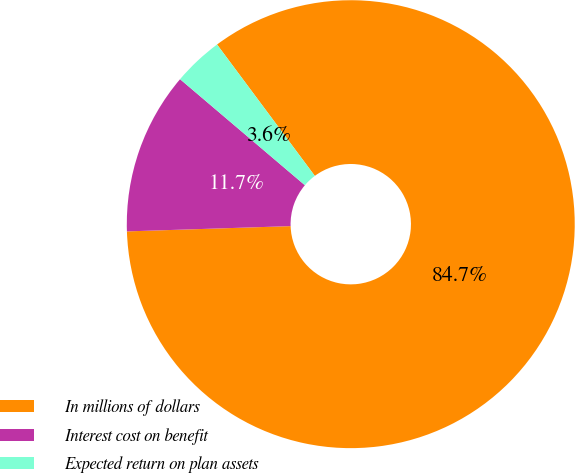Convert chart to OTSL. <chart><loc_0><loc_0><loc_500><loc_500><pie_chart><fcel>In millions of dollars<fcel>Interest cost on benefit<fcel>Expected return on plan assets<nl><fcel>84.67%<fcel>11.72%<fcel>3.61%<nl></chart> 